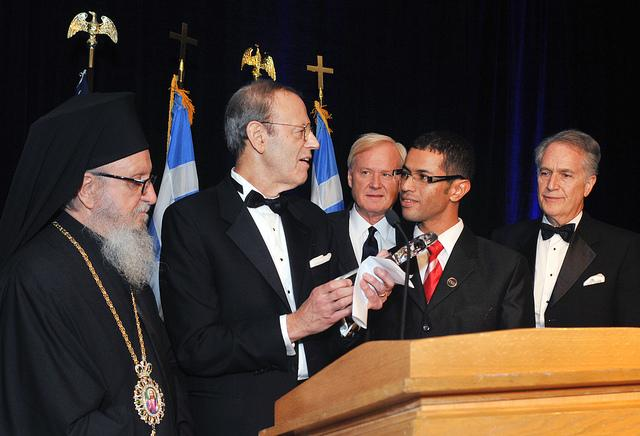The man on the left is probably a member of what type of group? muslim 